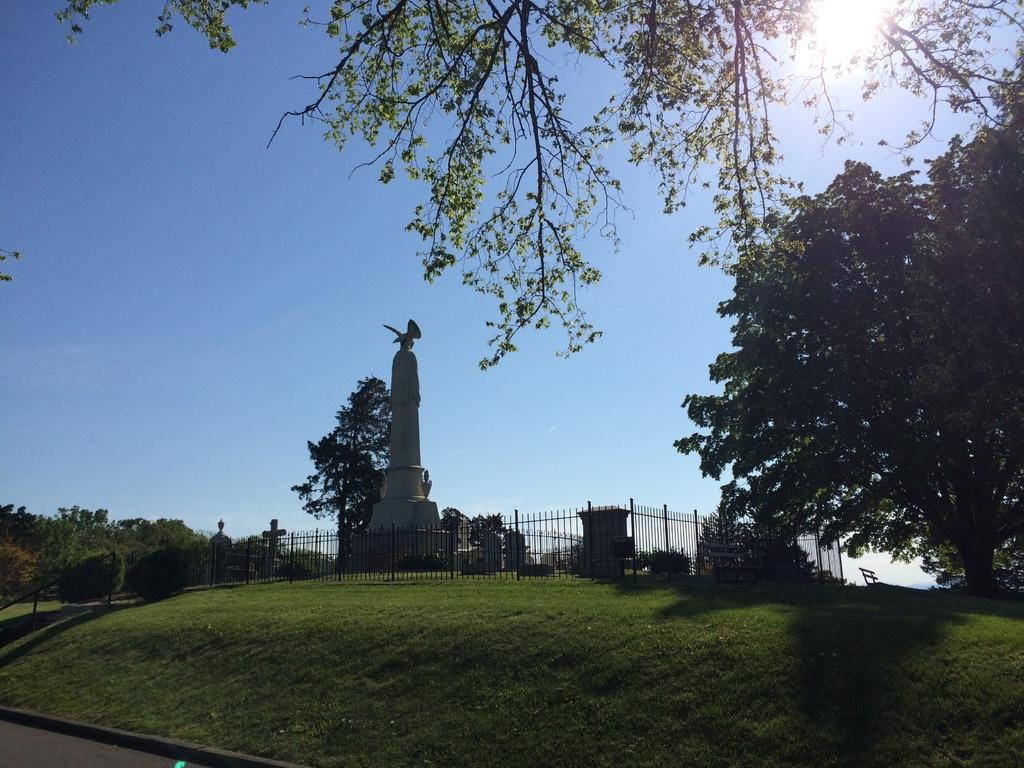What is the main subject in the center of the image? There is a statue in the center of the image. What type of barrier is present in the image? There is a metal fence in the image. How is the metal fence positioned in the image? The metal fence is placed across on the ground. What can be seen in the background of the image? There is a bench, a group of trees, metal poles, and the sky visible in the background of the image. What type of sweater is the statue wearing in the image? The statue is not wearing a sweater in the image; it is a sculpture made of a material that does not require clothing. 